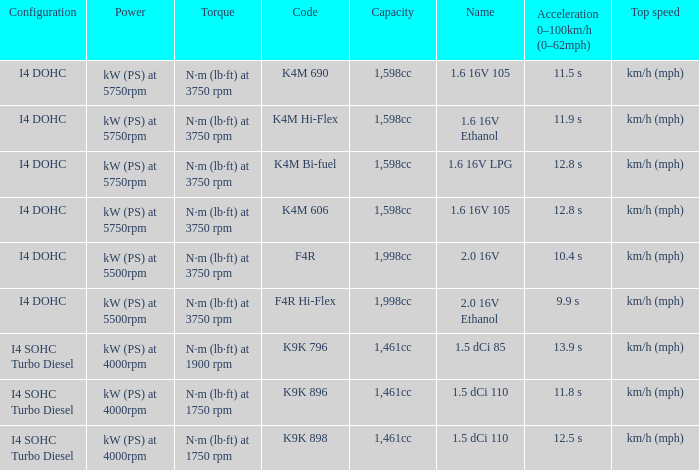What is the capacity of code f4r? 1,998cc. 